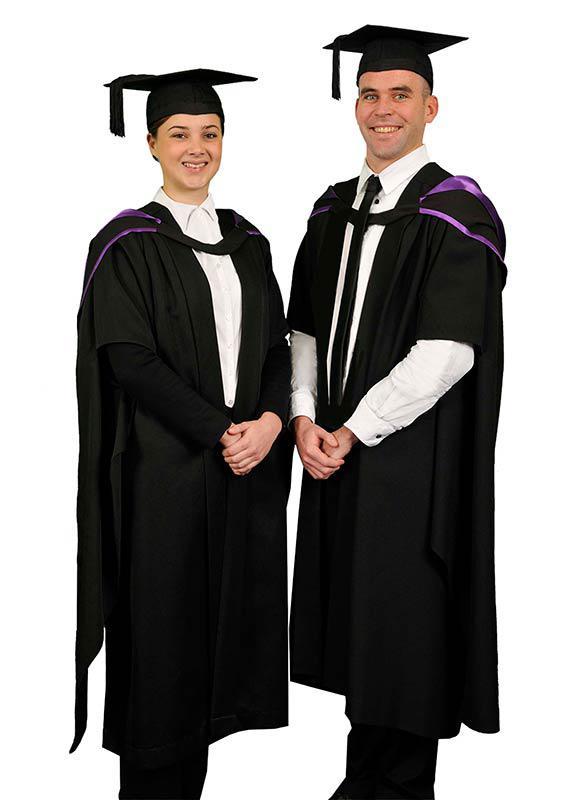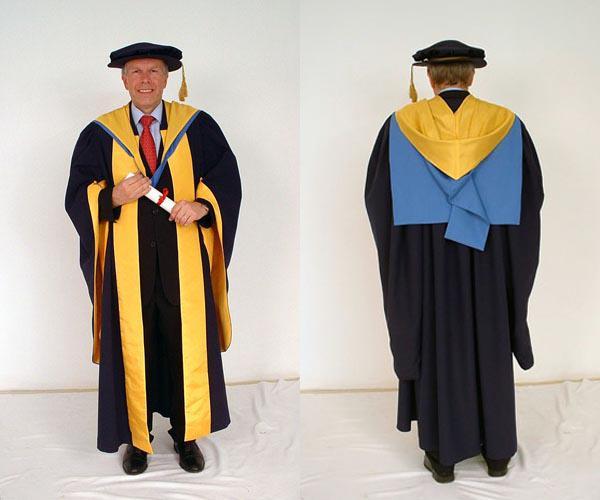The first image is the image on the left, the second image is the image on the right. Assess this claim about the two images: "At least one gown has a long gold embellishment.". Correct or not? Answer yes or no. Yes. 